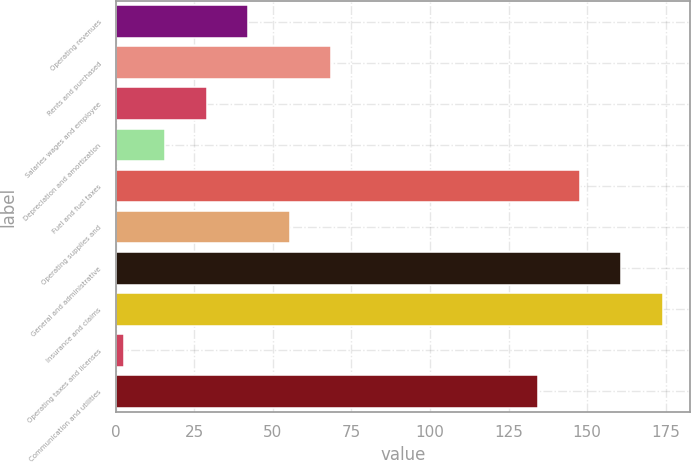Convert chart. <chart><loc_0><loc_0><loc_500><loc_500><bar_chart><fcel>Operating revenues<fcel>Rents and purchased<fcel>Salaries wages and employee<fcel>Depreciation and amortization<fcel>Fuel and fuel taxes<fcel>Operating supplies and<fcel>General and administrative<fcel>Insurance and claims<fcel>Operating taxes and licenses<fcel>Communication and utilities<nl><fcel>42.1<fcel>68.5<fcel>28.9<fcel>15.7<fcel>147.7<fcel>55.3<fcel>160.9<fcel>174.1<fcel>2.5<fcel>134.5<nl></chart> 